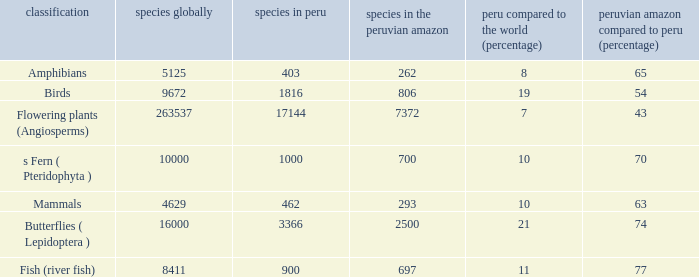What's the total number of species in the peruvian amazon with 8411 species in the world  1.0. 